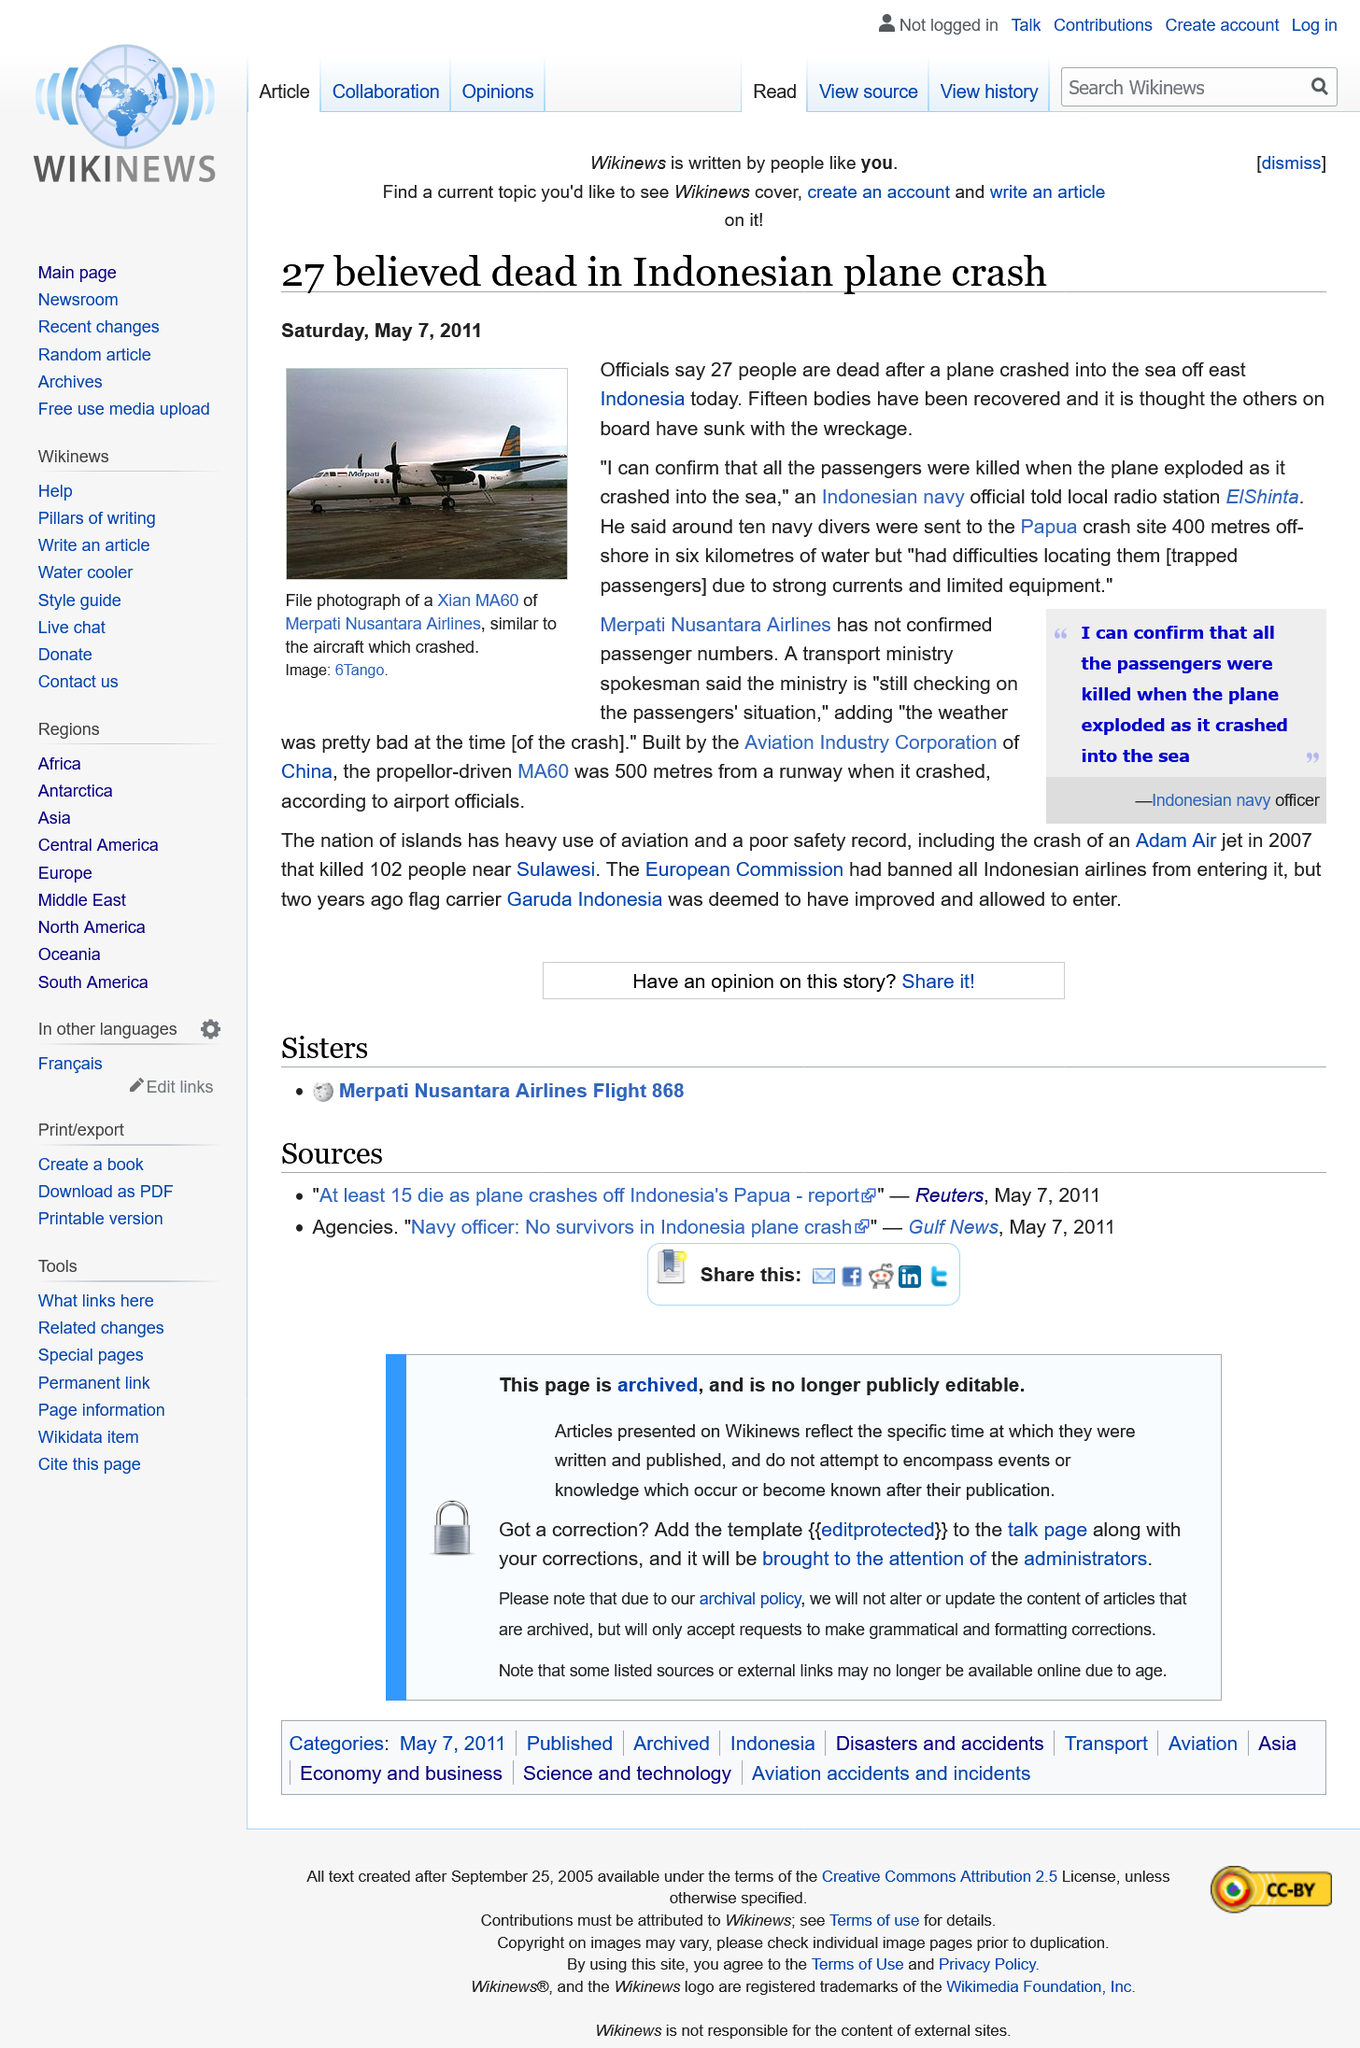Specify some key components in this picture. The plane crashed into the sea off the coast of East Indonesia. The main cause of death was the plane's explosion which resulted in its crash into the sea. The death toll has risen to 27, but the exact number of passengers aboard the vessel is still unknown. 